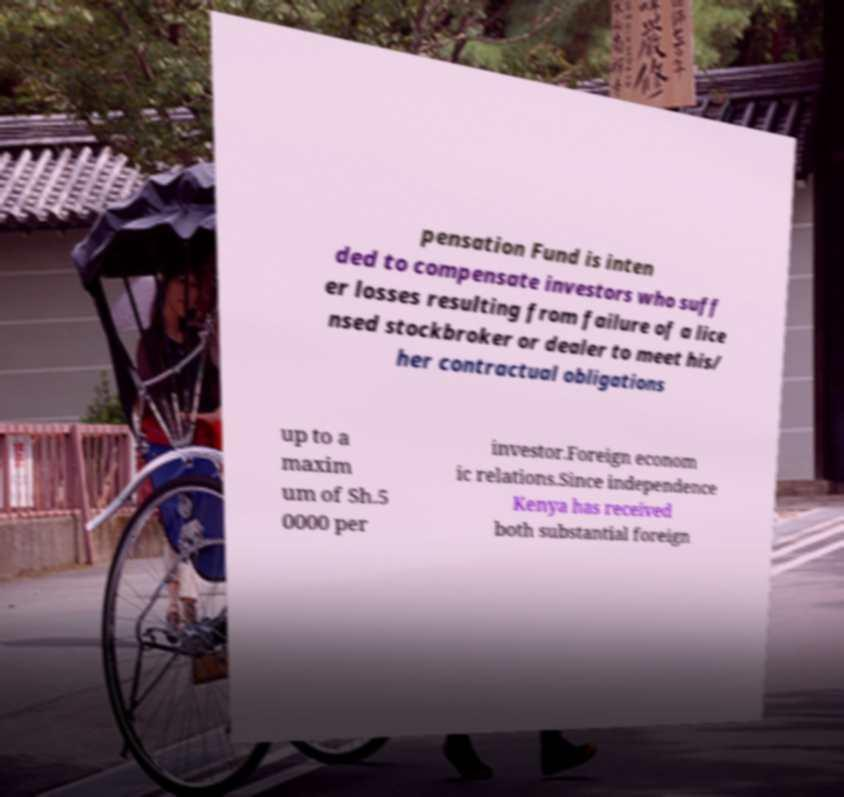I need the written content from this picture converted into text. Can you do that? pensation Fund is inten ded to compensate investors who suff er losses resulting from failure of a lice nsed stockbroker or dealer to meet his/ her contractual obligations up to a maxim um of Sh.5 0000 per investor.Foreign econom ic relations.Since independence Kenya has received both substantial foreign 